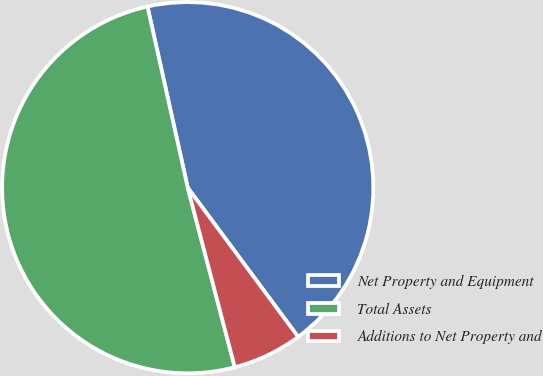<chart> <loc_0><loc_0><loc_500><loc_500><pie_chart><fcel>Net Property and Equipment<fcel>Total Assets<fcel>Additions to Net Property and<nl><fcel>43.34%<fcel>50.6%<fcel>6.06%<nl></chart> 